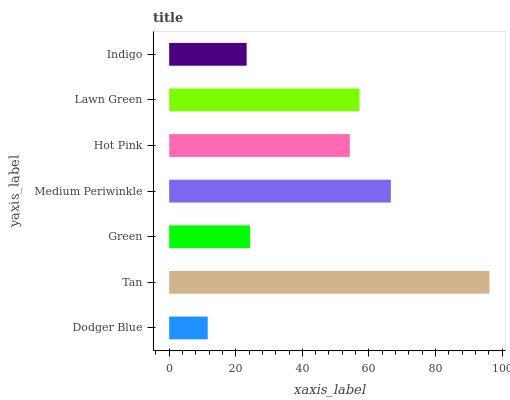Is Dodger Blue the minimum?
Answer yes or no. Yes. Is Tan the maximum?
Answer yes or no. Yes. Is Green the minimum?
Answer yes or no. No. Is Green the maximum?
Answer yes or no. No. Is Tan greater than Green?
Answer yes or no. Yes. Is Green less than Tan?
Answer yes or no. Yes. Is Green greater than Tan?
Answer yes or no. No. Is Tan less than Green?
Answer yes or no. No. Is Hot Pink the high median?
Answer yes or no. Yes. Is Hot Pink the low median?
Answer yes or no. Yes. Is Medium Periwinkle the high median?
Answer yes or no. No. Is Indigo the low median?
Answer yes or no. No. 